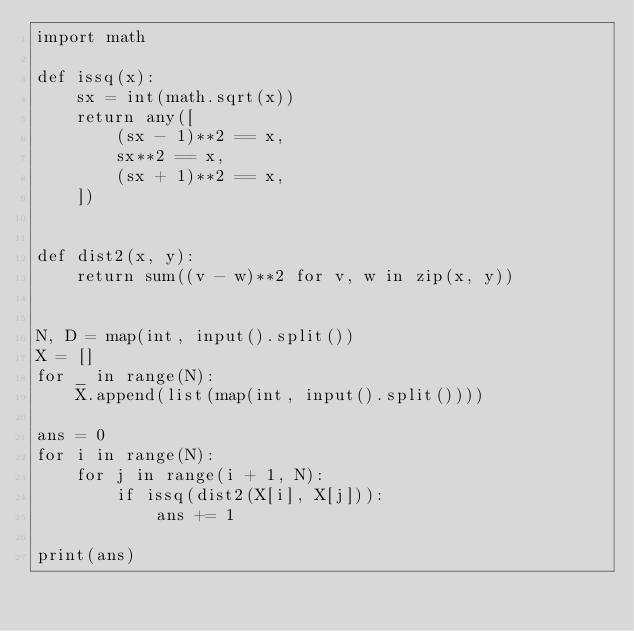Convert code to text. <code><loc_0><loc_0><loc_500><loc_500><_Python_>import math

def issq(x):
    sx = int(math.sqrt(x))
    return any([
        (sx - 1)**2 == x,
        sx**2 == x,
        (sx + 1)**2 == x,
    ])


def dist2(x, y):
    return sum((v - w)**2 for v, w in zip(x, y))


N, D = map(int, input().split())
X = []
for _ in range(N):
    X.append(list(map(int, input().split())))

ans = 0
for i in range(N):
    for j in range(i + 1, N):
        if issq(dist2(X[i], X[j])):
            ans += 1

print(ans)
</code> 